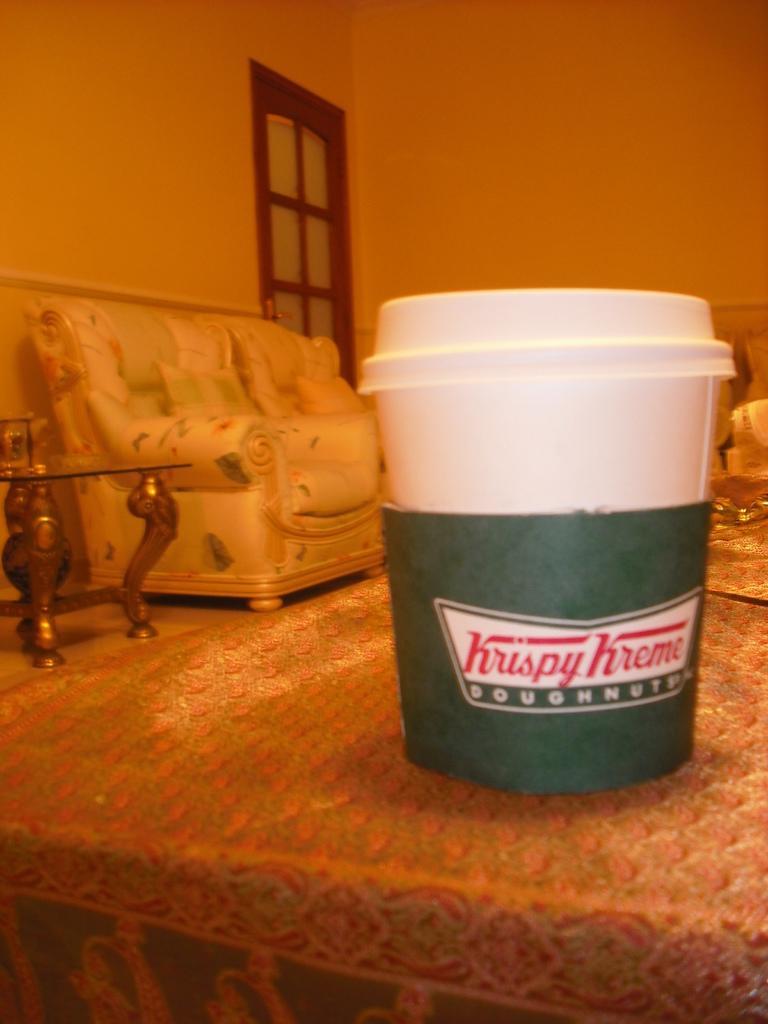Describe this image in one or two sentences. In this picture, there is a cup placed on the table. Towards the left, there is a sofa and a table. In the background, there is a wall with a window. 